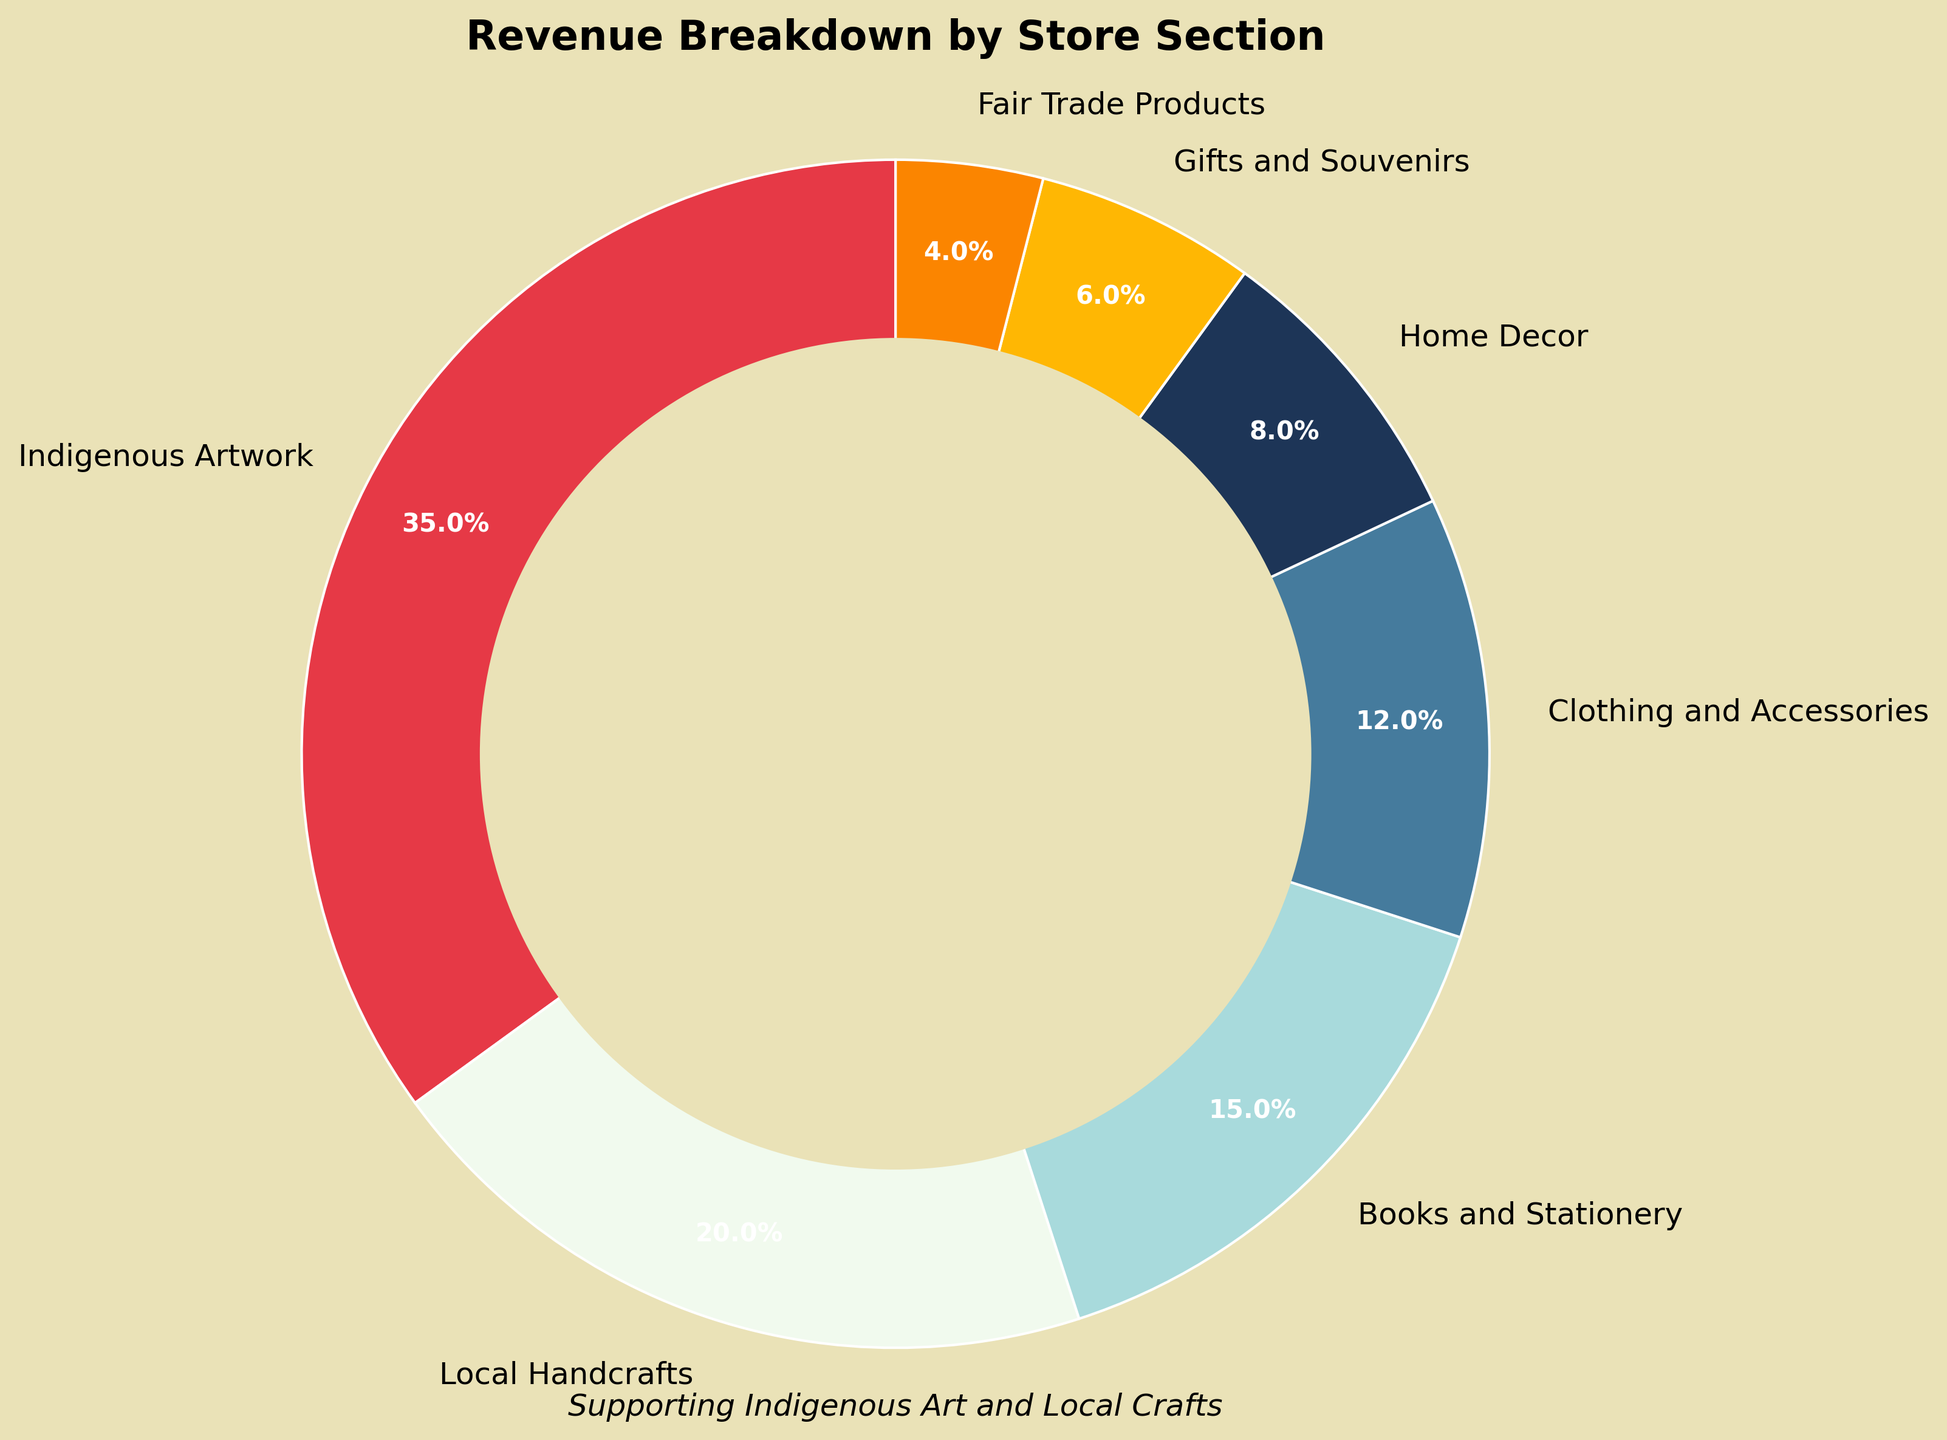What's the largest revenue-generating section? The largest section can be identified by looking at the percentage values. Indigenous Artwork has the highest percentage at 35%.
Answer: Indigenous Artwork Which section contributes the least to the revenue? The smallest section will have the lowest percentage value. Fair Trade Products has the lowest percentage at 4%.
Answer: Fair Trade Products How much revenue is generated from Books and Stationery and Clothing and Accessories combined? Add the percentages of Books and Stationery (15%) and Clothing and Accessories (12%). 15% + 12% = 27%
Answer: 27% Is the revenue from Local Handcrafts higher than from Home Decor? Compare the percentages of Local Handcrafts (20%) and Home Decor (8%). 20% is greater than 8%.
Answer: Yes What is the difference in revenue percentages between Gifts and Souvenirs and Fair Trade Products? Subtract the percentage of Fair Trade Products (4%) from Gifts and Souvenirs (6%). 6% - 4% = 2%
Answer: 2% What is the combined revenue percentage of the four smallest sections? Add the percentages of the four smallest sections: Home Decor (8%), Gifts and Souvenirs (6%), Fair Trade Products (4%), and Clothing and Accessories (12%). 8% + 6% + 4% + 12% = 30%
Answer: 30% Which section has a revenue percentage between 10% and 20%? Look for the sections with percentages in the given range. Clothing and Accessories has 12%, and Books and Stationery has 15%.
Answer: Books and Stationery and Clothing and Accessories How does the revenue percentage of Indigenous Artwork compare to that of Local Handcrafts? Indigenous Artwork has 35%, and Local Handcrafts has 20%. Since 35% is greater than 20%, Indigenous Artwork generates more revenue.
Answer: Higher What is the average revenue percentage of all sections? Sum up all percentages and divide by the number of sections. (35 + 20 + 15 + 12 + 8 + 6 + 4) / 7. Total is 100%, so 100/7 = 14.29%.
Answer: 14.29% How much more revenue does Indigenous Artwork generate compared to the Home Decor section? Subtract the percentage of Home Decor (8%) from Indigenous Artwork (35%). 35% - 8% = 27%
Answer: 27% 